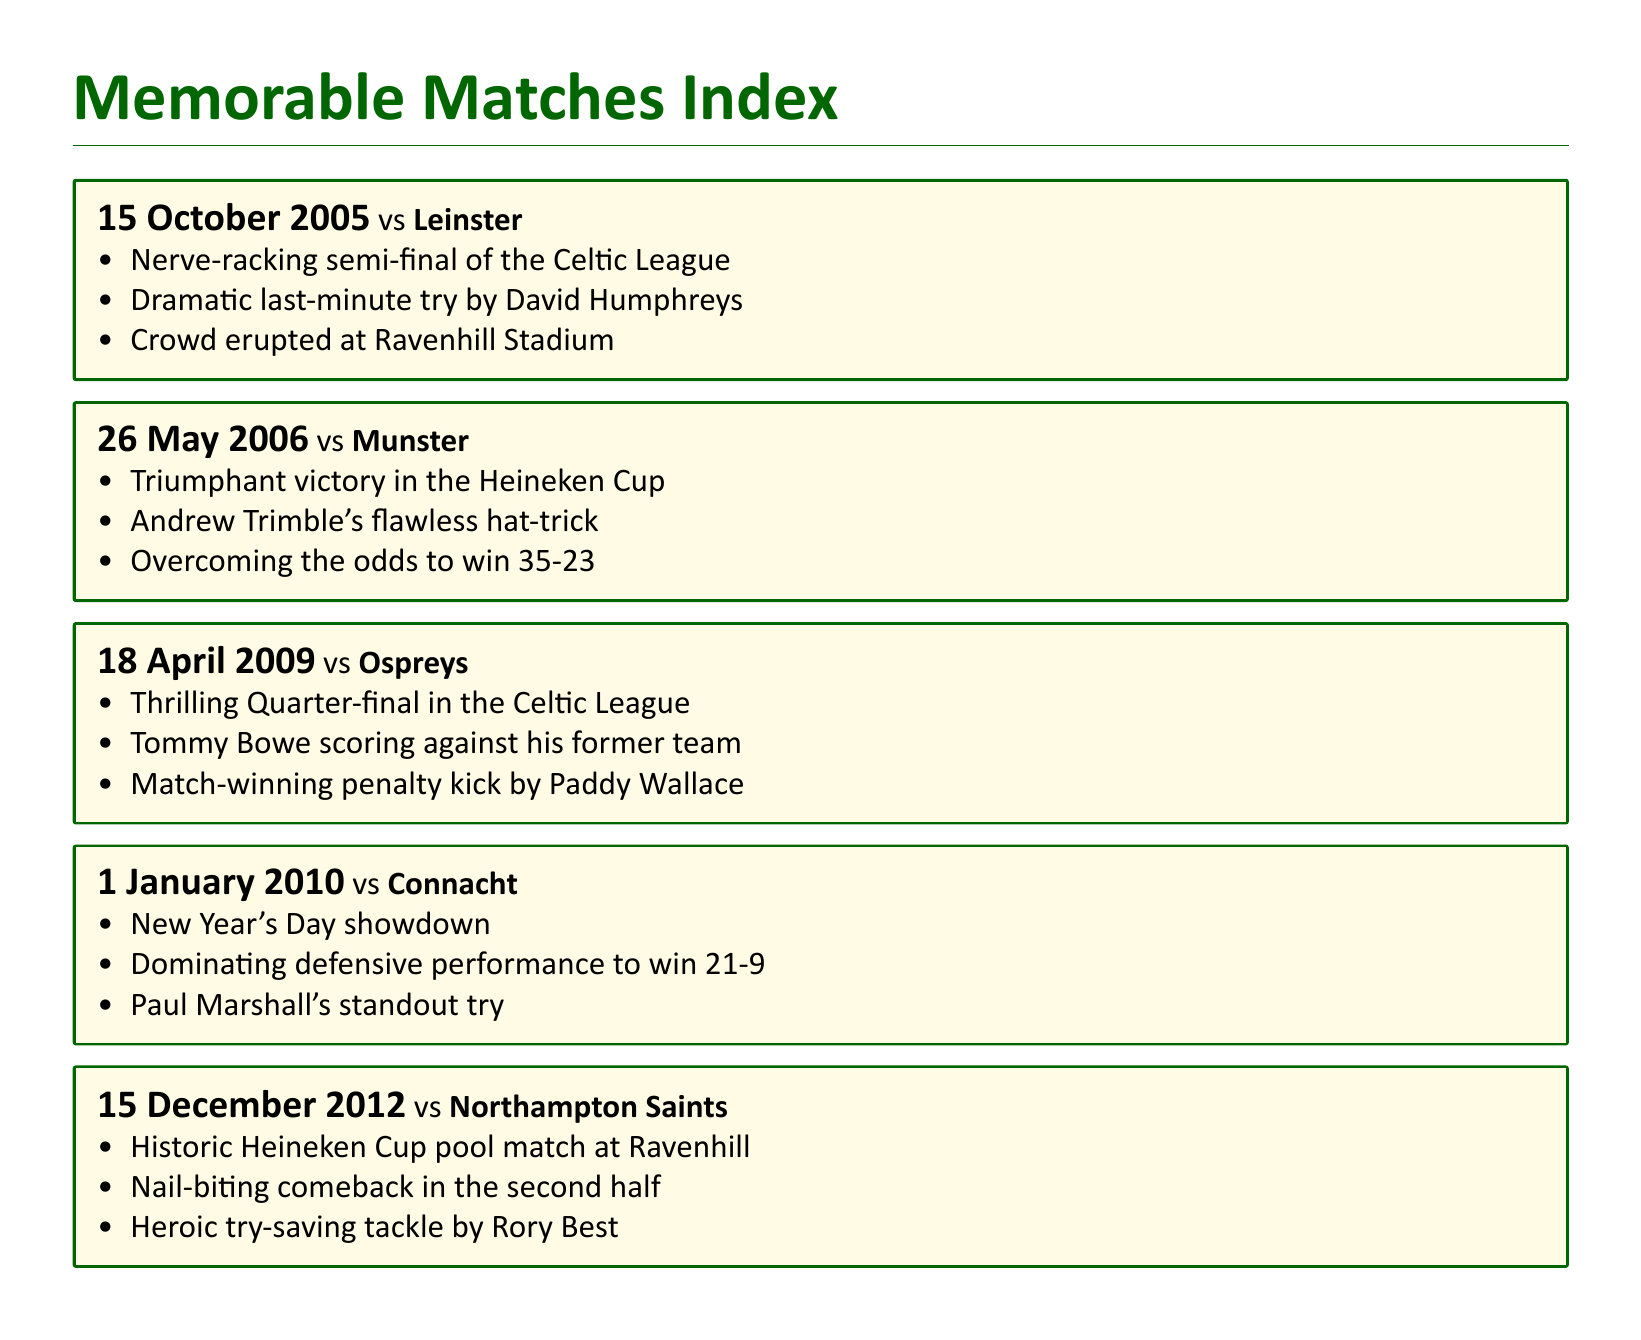What was the date of the match against Leinster? The match against Leinster took place on 15 October 2005.
Answer: 15 October 2005 Who scored a hat-trick in the Heineken Cup match? Andrew Trimble scored a flawless hat-trick in the match against Munster.
Answer: Andrew Trimble What was the score of the match against Munster? The final score of the match against Munster was 35-23.
Answer: 35-23 Which team did Tommy Bowe score against? Tommy Bowe scored against Ospreys, his former team, in the match.
Answer: Ospreys What was the key moment in the match against Northampton Saints? A nail-biting comeback in the second half was a key moment in the match against Northampton Saints.
Answer: Nail-biting comeback Which match featured a dramatic last-minute try? The semi-final against Leinster featured a dramatic last-minute try by David Humphreys.
Answer: Leinster How many memorable matches are listed in the document? The document lists a total of five memorable matches.
Answer: Five What was the notable performance in the match on New Year's Day? The notable performance in the New Year's Day match was a dominating defensive performance.
Answer: Dominating defensive performance Which player made a standout tackle in the match against Northampton Saints? Rory Best made a heroic try-saving tackle in the match against Northampton Saints.
Answer: Rory Best 